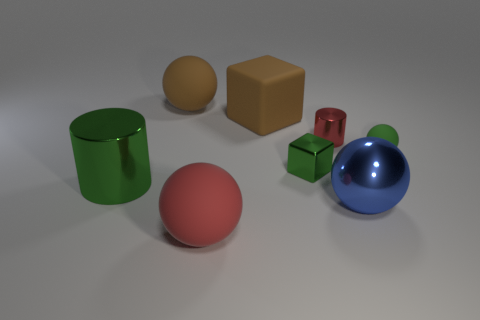Add 1 big brown blocks. How many objects exist? 9 Subtract all brown spheres. How many spheres are left? 3 Subtract all cubes. How many objects are left? 6 Subtract 1 blocks. How many blocks are left? 1 Subtract all large objects. Subtract all green cylinders. How many objects are left? 2 Add 6 big shiny things. How many big shiny things are left? 8 Add 8 green shiny cubes. How many green shiny cubes exist? 9 Subtract all red spheres. How many spheres are left? 3 Subtract 0 cyan spheres. How many objects are left? 8 Subtract all blue balls. Subtract all blue cubes. How many balls are left? 3 